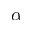<formula> <loc_0><loc_0><loc_500><loc_500>\alpha</formula> 